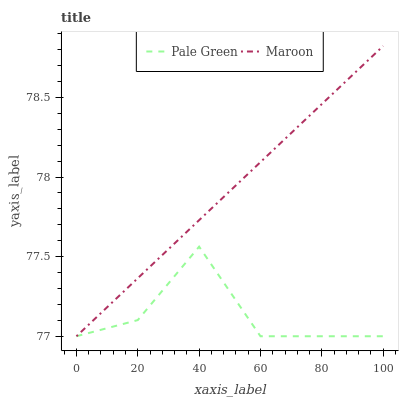Does Pale Green have the minimum area under the curve?
Answer yes or no. Yes. Does Maroon have the maximum area under the curve?
Answer yes or no. Yes. Does Maroon have the minimum area under the curve?
Answer yes or no. No. Is Maroon the smoothest?
Answer yes or no. Yes. Is Pale Green the roughest?
Answer yes or no. Yes. Is Maroon the roughest?
Answer yes or no. No. Does Pale Green have the lowest value?
Answer yes or no. Yes. Does Maroon have the highest value?
Answer yes or no. Yes. Does Pale Green intersect Maroon?
Answer yes or no. Yes. Is Pale Green less than Maroon?
Answer yes or no. No. Is Pale Green greater than Maroon?
Answer yes or no. No. 